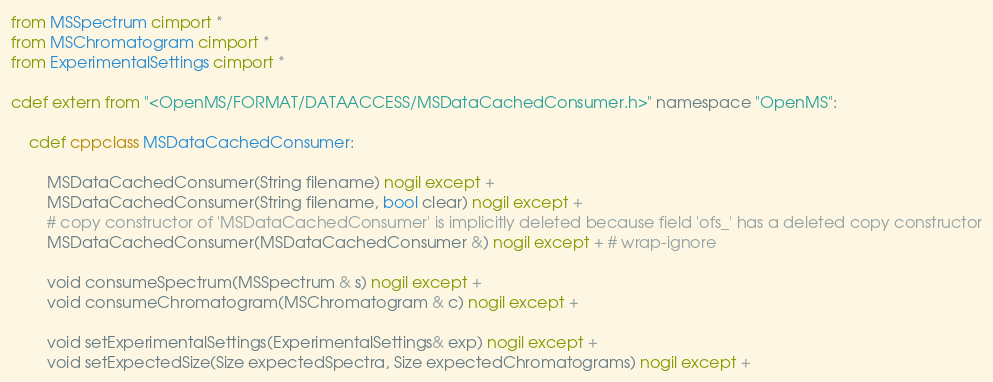<code> <loc_0><loc_0><loc_500><loc_500><_Cython_>from MSSpectrum cimport *
from MSChromatogram cimport *
from ExperimentalSettings cimport *

cdef extern from "<OpenMS/FORMAT/DATAACCESS/MSDataCachedConsumer.h>" namespace "OpenMS":

    cdef cppclass MSDataCachedConsumer:

        MSDataCachedConsumer(String filename) nogil except +
        MSDataCachedConsumer(String filename, bool clear) nogil except +
        # copy constructor of 'MSDataCachedConsumer' is implicitly deleted because field 'ofs_' has a deleted copy constructor
        MSDataCachedConsumer(MSDataCachedConsumer &) nogil except + # wrap-ignore

        void consumeSpectrum(MSSpectrum & s) nogil except +
        void consumeChromatogram(MSChromatogram & c) nogil except +

        void setExperimentalSettings(ExperimentalSettings& exp) nogil except +
        void setExpectedSize(Size expectedSpectra, Size expectedChromatograms) nogil except +

</code> 